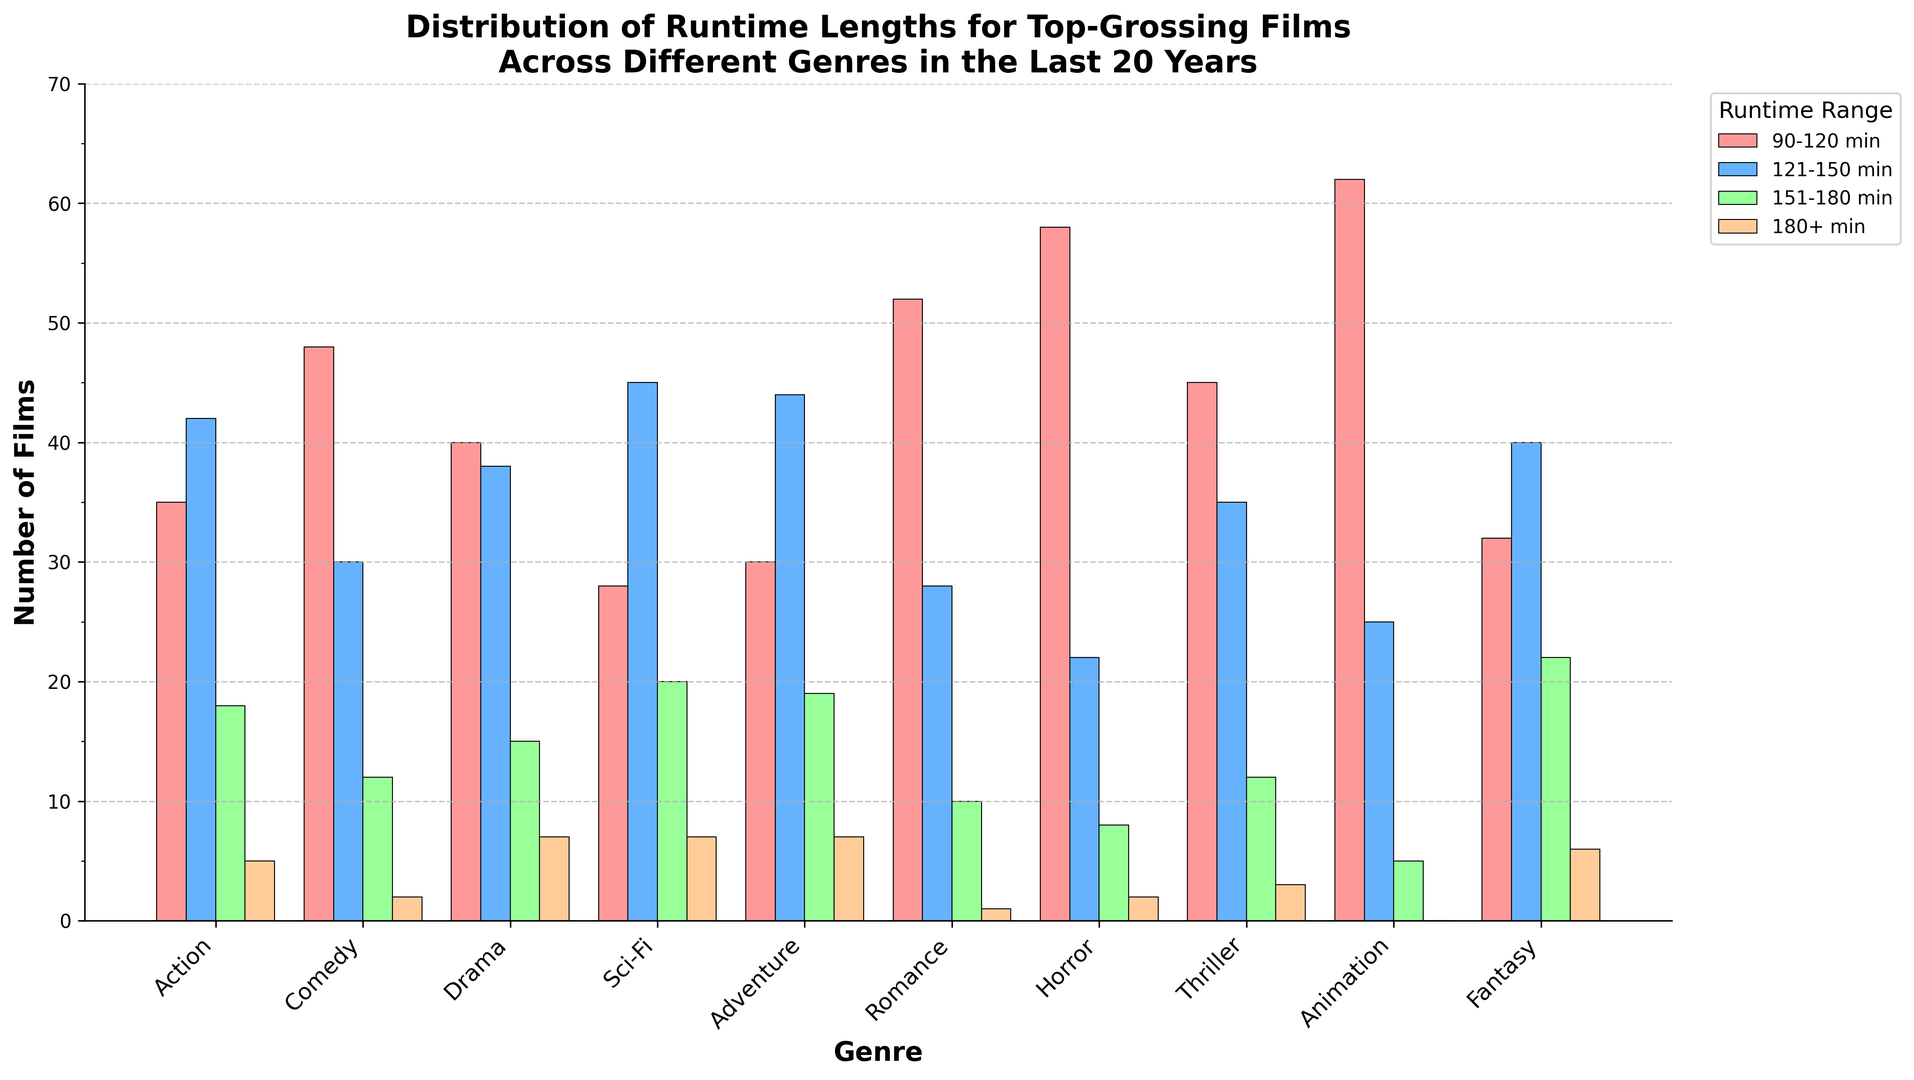What genre has the highest number of films with a runtime of 90-120 min? Looking at the bar heights, the highest bar within the 90-120 min runtime range is Animation. This bar is much taller compared to other bars in the same runtime range for different genres.
Answer: Animation Which genre has the fewest films that exceed 180 minutes in runtime? Comparing the bars in the 180+ min range, the shortest bars belong to Animation and Romance. Animation has 0 films in this category, while Romance has 1. Hence, Animation has the fewest.
Answer: Animation What is the total number of drama films across all runtime categories? By summing the numbers in the Drama row: 40 (90-120 min) + 38 (121-150 min) + 15 (151-180 min) + 7 (180+ min) = 100.
Answer: 100 Between Action and Thriller genres, which one has more films with runtimes between 121-150 min? By comparing the bar heights in the 121-150 min range for both genres, Action has 42 films while Thriller has 35. Hence, Action has more.
Answer: Action Which runtime category has the highest number of Sci-Fi films? Looking at the bars for Sci-Fi, the highest one is in the 121-150 min range with 45 films.
Answer: 121-150 min What is the difference in the number of Comedy films between the 90-120 min and 151-180 min categories? Subtract the number of Comedy films in the 151-180 min range from the 90-120 min range: 48 (90-120 min) - 12 (151-180 min) = 36.
Answer: 36 Which genre has the most evenly distributed runtime lengths across all categories? By inspecting the height of bars, Drama has a fairly even distribution with values of 40, 38, 15, and 7 across the four runtime categories.
Answer: Drama How many genres have at least 60 films within the 90-120 min runtime? Checking the 90-120 min runtime bars, Animation has 62 films in this category. This is the only genre with at least 60 films.
Answer: 1 What is the sum of films that are 180+ min across Romance, Horror, and Thriller? Adding up the number of films in the 180+ min category for these genres: 1 (Romance) + 2 (Horror) + 3 (Thriller) = 6.
Answer: 6 Between Fantasy and Adventure genres, which one has more films in the 151-180 min runtime? Comparing the bars in the 151-180 min range, Fantasy has 22 films while Adventure has 19. Hence, Fantasy has more.
Answer: Fantasy 